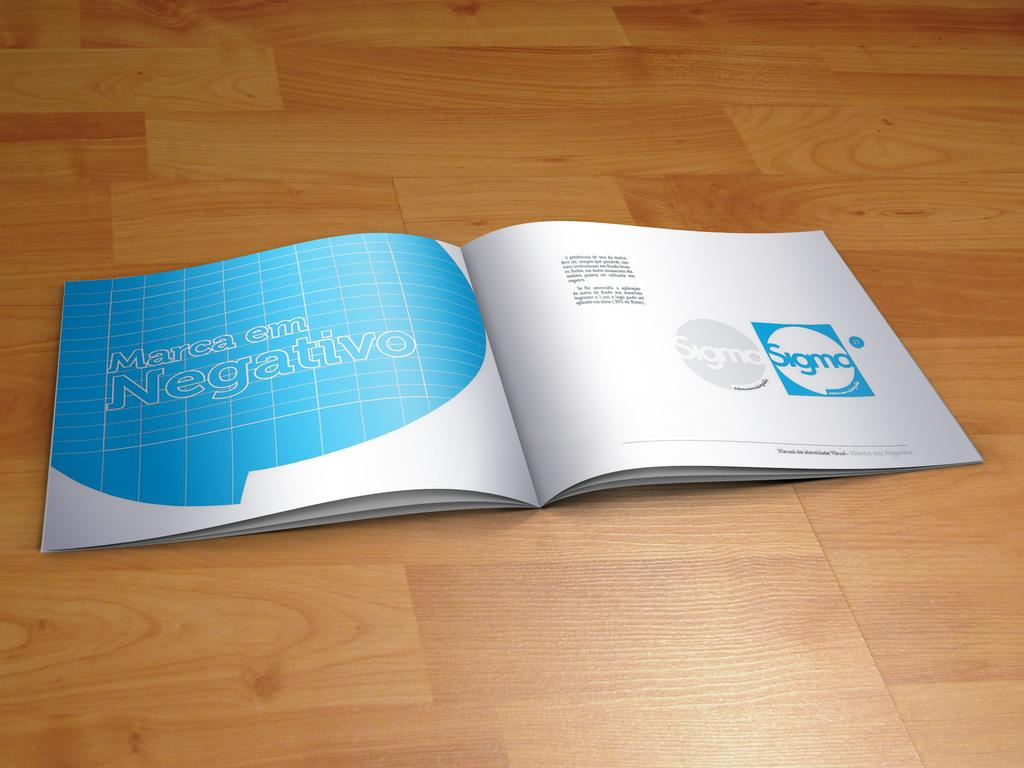Provide a one-sentence caption for the provided image. A rendering of an open book with the words "Marca em Negativo" on the left page. 